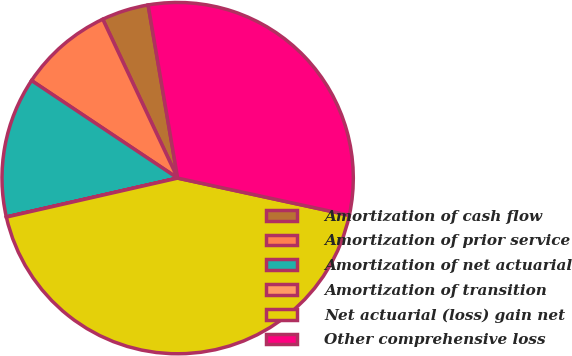<chart> <loc_0><loc_0><loc_500><loc_500><pie_chart><fcel>Amortization of cash flow<fcel>Amortization of prior service<fcel>Amortization of net actuarial<fcel>Amortization of transition<fcel>Net actuarial (loss) gain net<fcel>Other comprehensive loss<nl><fcel>4.32%<fcel>8.62%<fcel>12.92%<fcel>0.01%<fcel>43.04%<fcel>31.08%<nl></chart> 